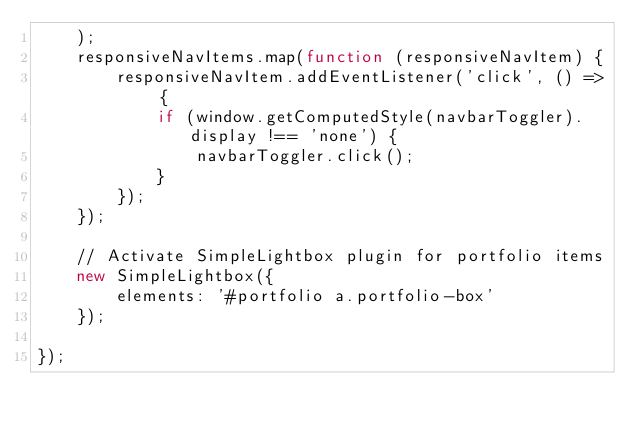Convert code to text. <code><loc_0><loc_0><loc_500><loc_500><_JavaScript_>    );
    responsiveNavItems.map(function (responsiveNavItem) {
        responsiveNavItem.addEventListener('click', () => {
            if (window.getComputedStyle(navbarToggler).display !== 'none') {
                navbarToggler.click();
            }
        });
    });

    // Activate SimpleLightbox plugin for portfolio items
    new SimpleLightbox({
        elements: '#portfolio a.portfolio-box'
    });

});


</code> 